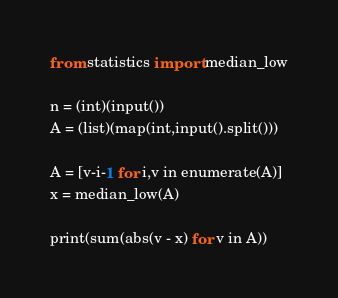<code> <loc_0><loc_0><loc_500><loc_500><_Python_>from statistics import median_low

n = (int)(input())
A = (list)(map(int,input().split()))

A = [v-i-1 for i,v in enumerate(A)]
x = median_low(A)

print(sum(abs(v - x) for v in A))
</code> 